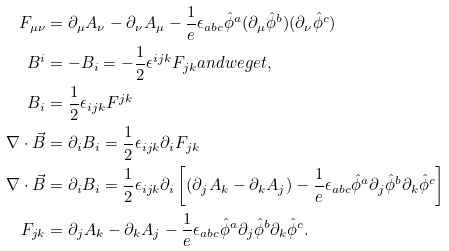<formula> <loc_0><loc_0><loc_500><loc_500>F _ { \mu \nu } & = \partial _ { \mu } A _ { \nu } - \partial _ { \nu } A _ { \mu } - \frac { 1 } { e } \epsilon _ { a b c } \hat { \phi } ^ { a } ( \partial _ { \mu } \hat { \phi } ^ { b } ) ( \partial _ { \nu } \hat { \phi } ^ { c } ) \\ B ^ { i } & = - B _ { i } = - \frac { 1 } { 2 } \epsilon ^ { i j k } F _ { j k } a n d w e g e t , \\ B _ { i } & = \frac { 1 } { 2 } \epsilon _ { i j k } F ^ { j k } \\ \nabla \cdot \vec { B } & = \partial _ { i } B _ { i } = \frac { 1 } { 2 } \epsilon _ { i j k } \partial _ { i } F _ { j k } \\ \nabla \cdot \vec { B } & = \partial _ { i } B _ { i } = \frac { 1 } { 2 } \epsilon _ { i j k } \partial _ { i } \left [ ( \partial _ { j } A _ { k } - \partial _ { k } A _ { j } ) - \frac { 1 } { e } \epsilon _ { a b c } \hat { \phi } ^ { a } \partial _ { j } \hat { \phi } ^ { b } \partial _ { k } \hat { \phi } ^ { c } \right ] \\ F _ { j k } & = \partial _ { j } A _ { k } - \partial _ { k } A _ { j } - \frac { 1 } { e } \epsilon _ { a b c } \hat { \phi } ^ { a } \partial _ { j } \hat { \phi } ^ { b } \partial _ { k } \hat { \phi } ^ { c } .</formula> 